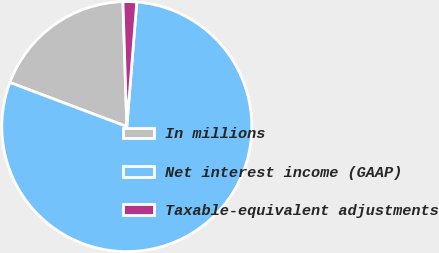Convert chart to OTSL. <chart><loc_0><loc_0><loc_500><loc_500><pie_chart><fcel>In millions<fcel>Net interest income (GAAP)<fcel>Taxable-equivalent adjustments<nl><fcel>18.77%<fcel>79.46%<fcel>1.76%<nl></chart> 